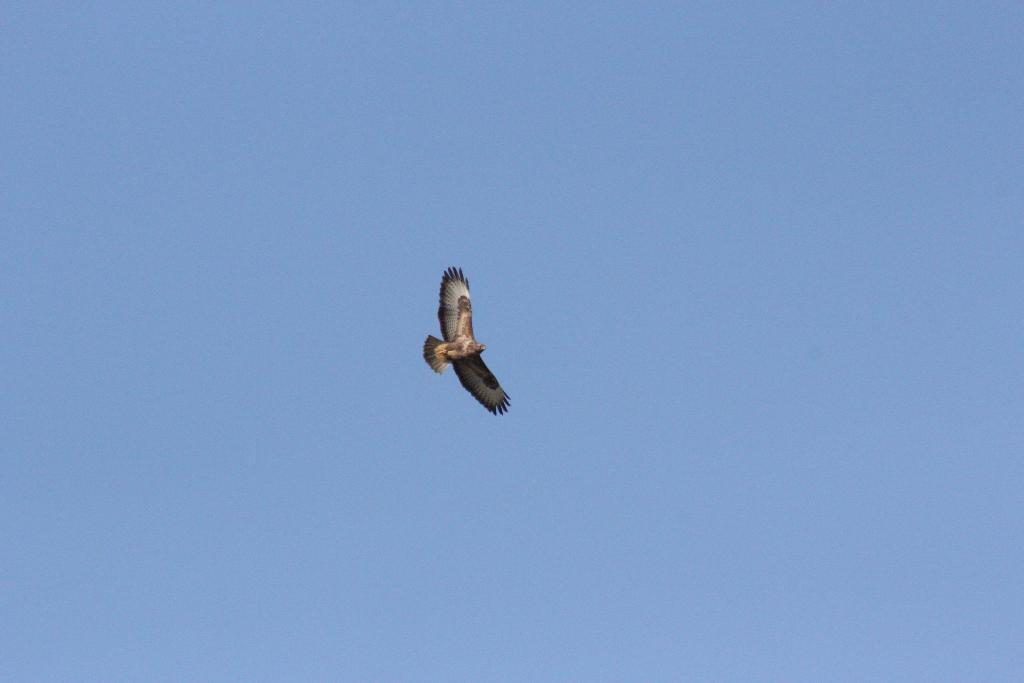What is the main subject of the image? There is a bird in the center of the image. Can you describe the bird's appearance? The bird has black, white, and brown colors. What can be seen in the background of the image? The sky is visible in the background of the image. How would you describe the sky's condition? The sky appears to be clear. What verse is the bird reciting in the image? There is no indication in the image that the bird is reciting a verse, as birds do not have the ability to speak or recite verses. 